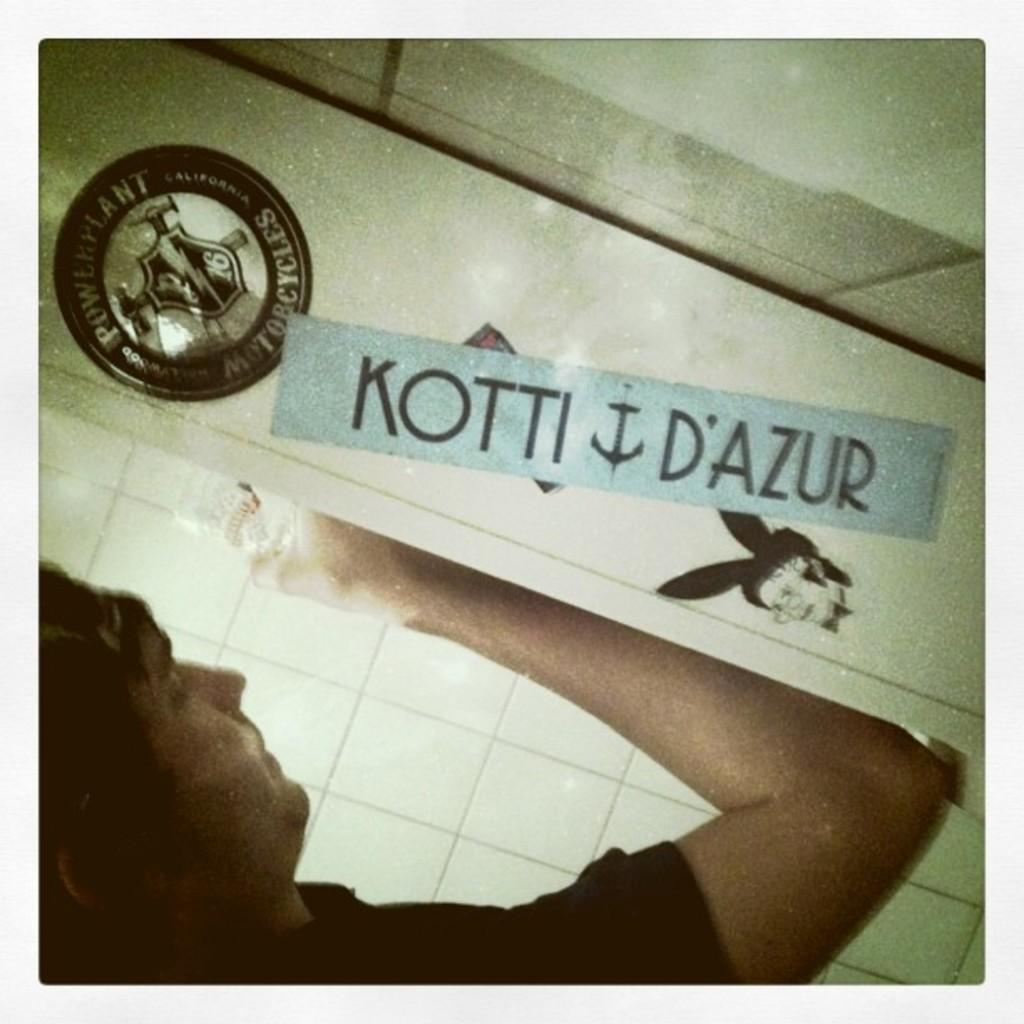Can you describe this image briefly? In this image I can see a person wearing black colored dress is holding an object in his hand and I can see a blue colored board, a black colored badge and few other objects. 